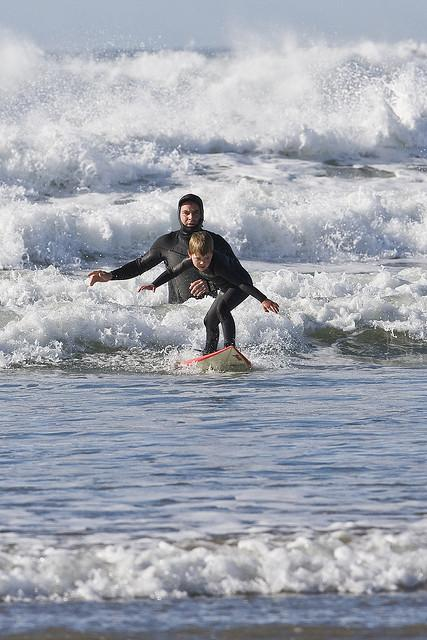Why are they dressed in black? keep warm 